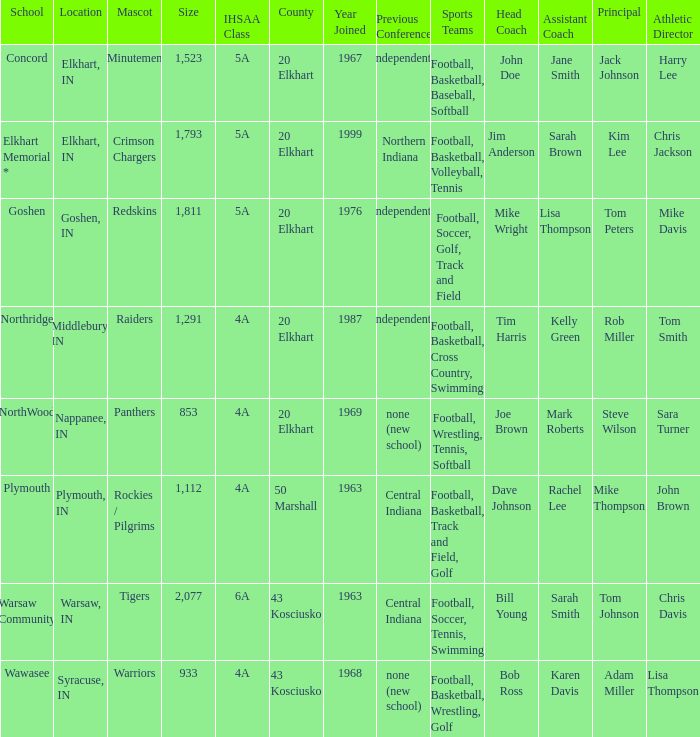What country joined before 1976, with IHSSA class of 5a, and a size larger than 1,112? 20 Elkhart. 